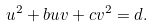Convert formula to latex. <formula><loc_0><loc_0><loc_500><loc_500>u ^ { 2 } + b u v + c v ^ { 2 } = d .</formula> 